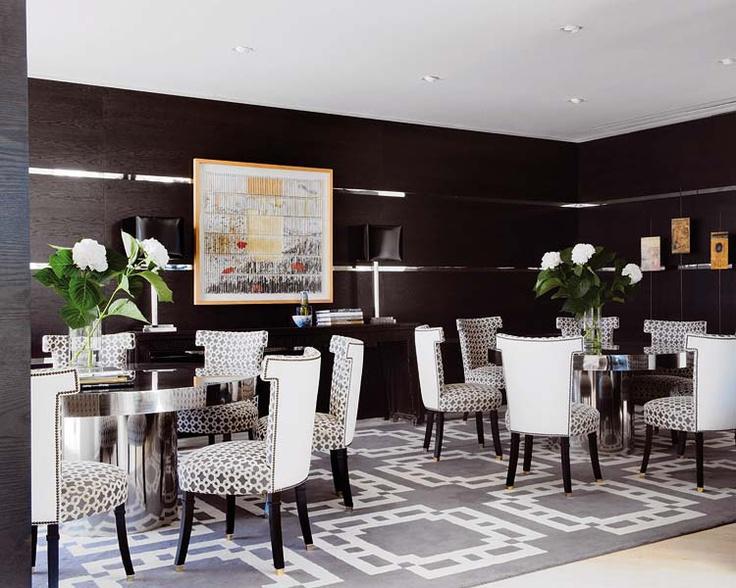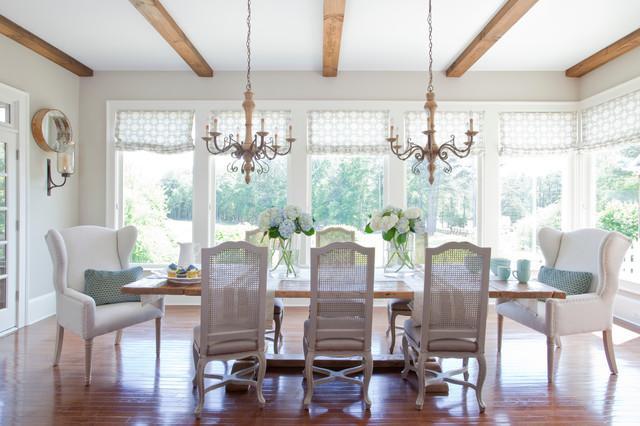The first image is the image on the left, the second image is the image on the right. Given the left and right images, does the statement "The right image shows two chandleliers suspended over a single table, and six chairs with curved legs are positioned by the table." hold true? Answer yes or no. Yes. The first image is the image on the left, the second image is the image on the right. Evaluate the accuracy of this statement regarding the images: "In at least one image there are two parallel kitchen table sets with at least one painting behind them". Is it true? Answer yes or no. Yes. 